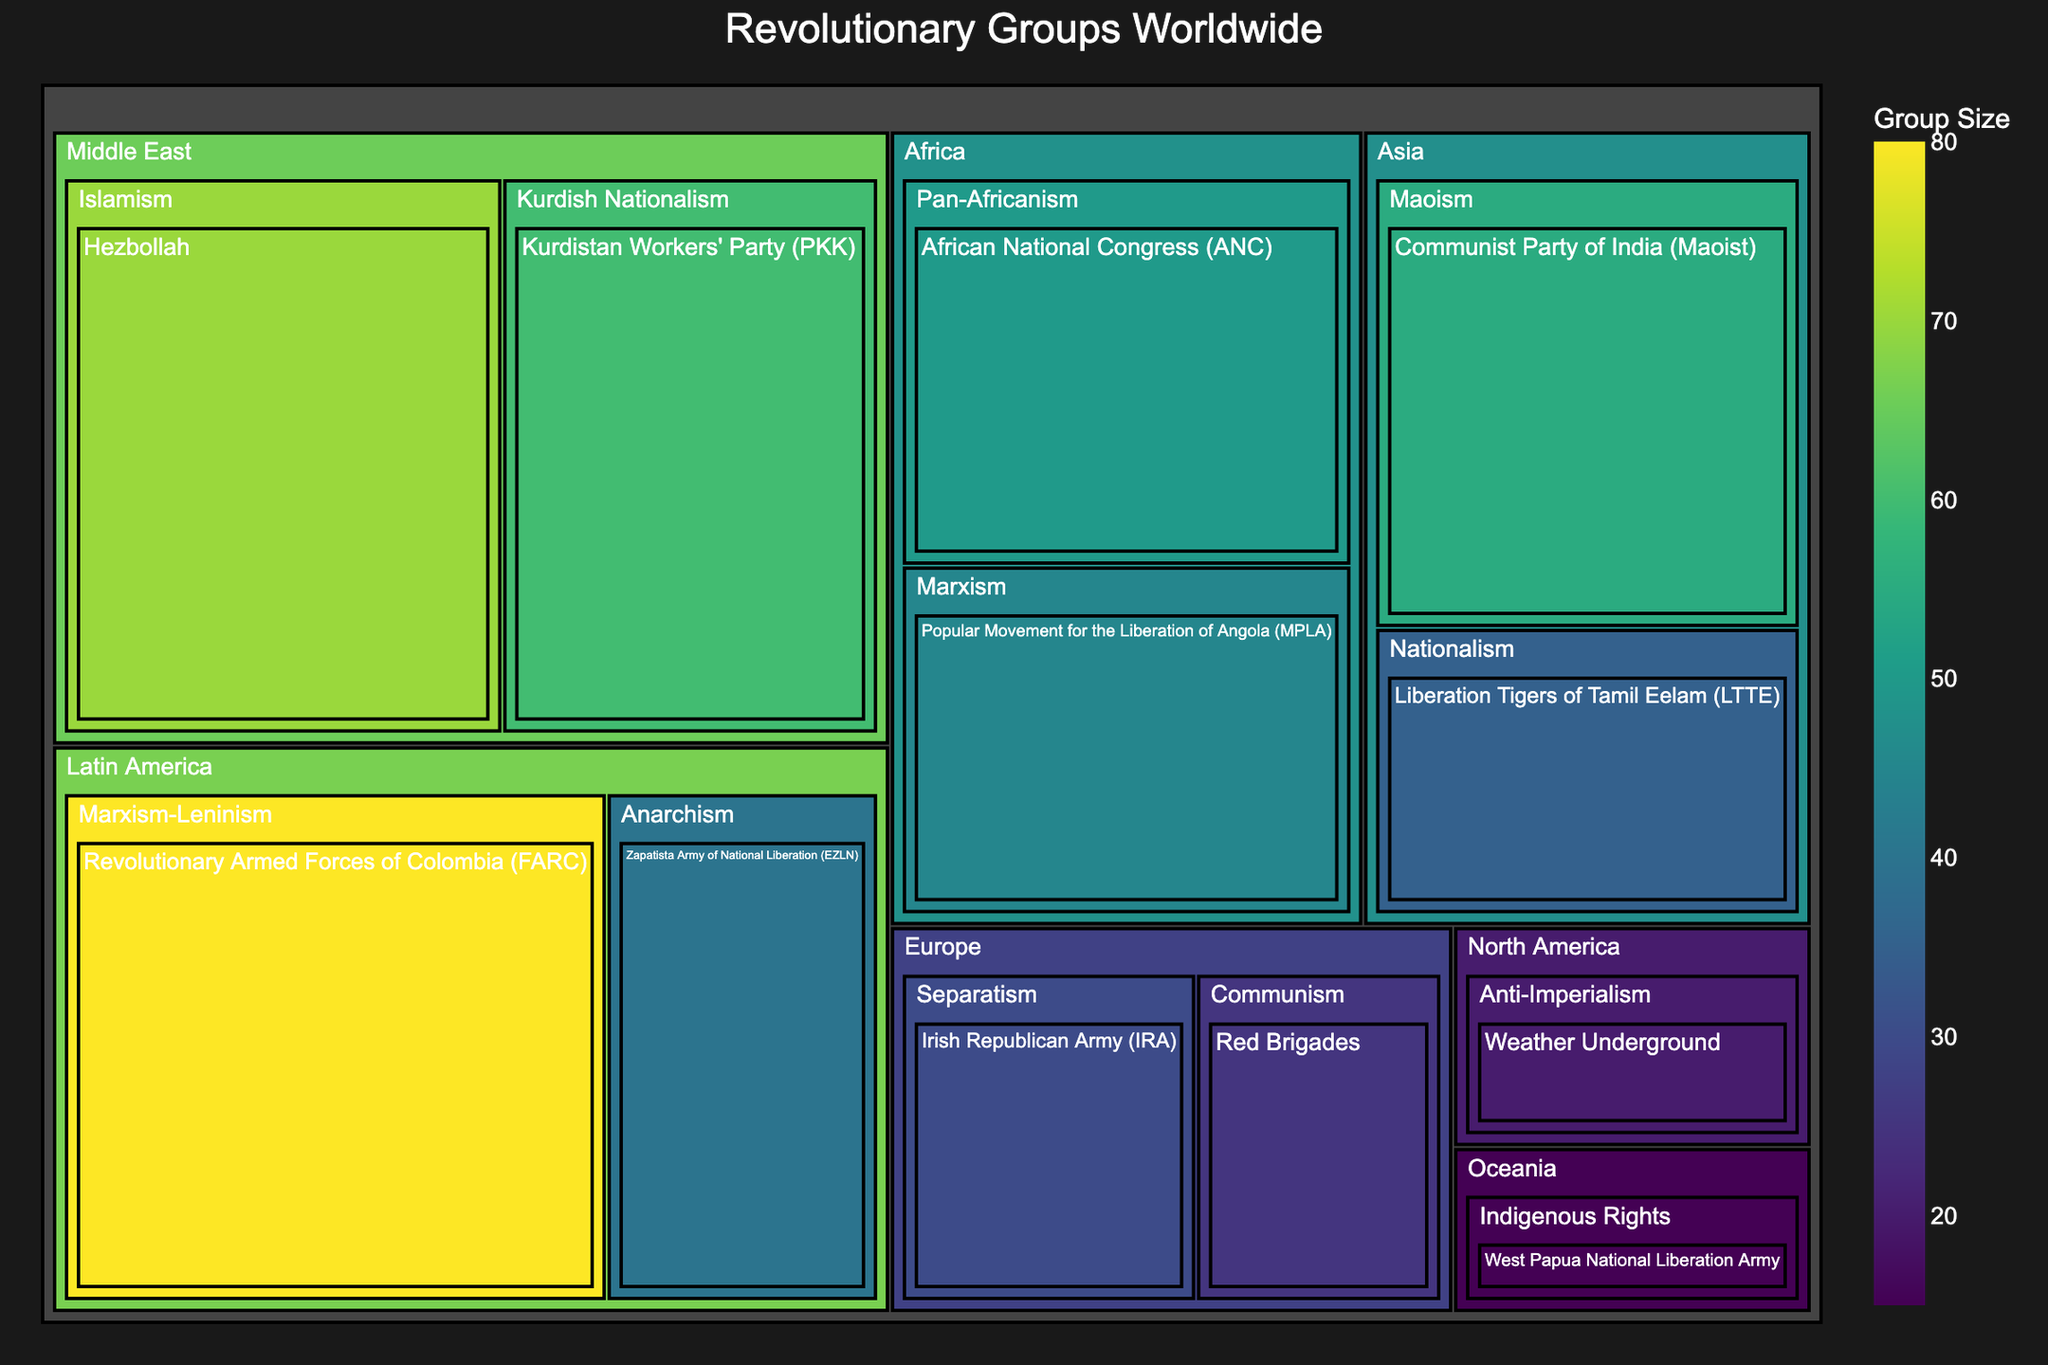what is the title of the figure? The title is typically displayed at the top of the treemap. Look for large, prominent text.
Answer: Revolutionary Groups Worldwide Which revolutionary group in Latin America has the largest size? The treemap shows multiple groups categorized by region and size. Find the largest block within the Latin America section.
Answer: Revolutionary Armed Forces of Colombia (FARC) How many groups are ideologically aligned with communism in Europe? In the Europe section, check the sub-categories for political philosophies. Count the number of groups under "Communism".
Answer: 1 What is the size difference between Hezbollah and Kurdistan Workers' Party (PKK)? Look at the Middle East section and note the size values for both Hezbollah and PKK. Subtract PKK's size from Hezbollah's size.
Answer: 10 Which region has the most diverse set of political philosophies? Examine the number of different political philosophies within each regional category. The region with the most unique philosophies is the most diverse.
Answer: Latin America What is the average size of revolutionary groups in Africa? Sum the sizes of all groups in Africa, then divide by the number of groups in Africa. Calculation: (50+45)/2
Answer: 47.5 Which revolutionary group has the smallest size? Scan through all regions and note the size values. Identify the group with the smallest value.
Answer: West Papua National Liberation Army Compare the sizes of Zapatista Army of National Liberation (EZLN) and the Liberation Tigers of Tamil Eelam (LTTE). Which one is larger? Locate both groups in their respective regions and compare their size values.
Answer: Zapatista Army of National Liberation (EZLN) How many revolutionary groups are there in total across all regions? Count each group displayed on the treemap.
Answer: 12 What is the combined size of all the Marxist-affiliated groups? Identify all groups with Marxist ideologies in different regions, then sum their sizes. Calculation: FARC (80) + MPLA (45)
Answer: 125 